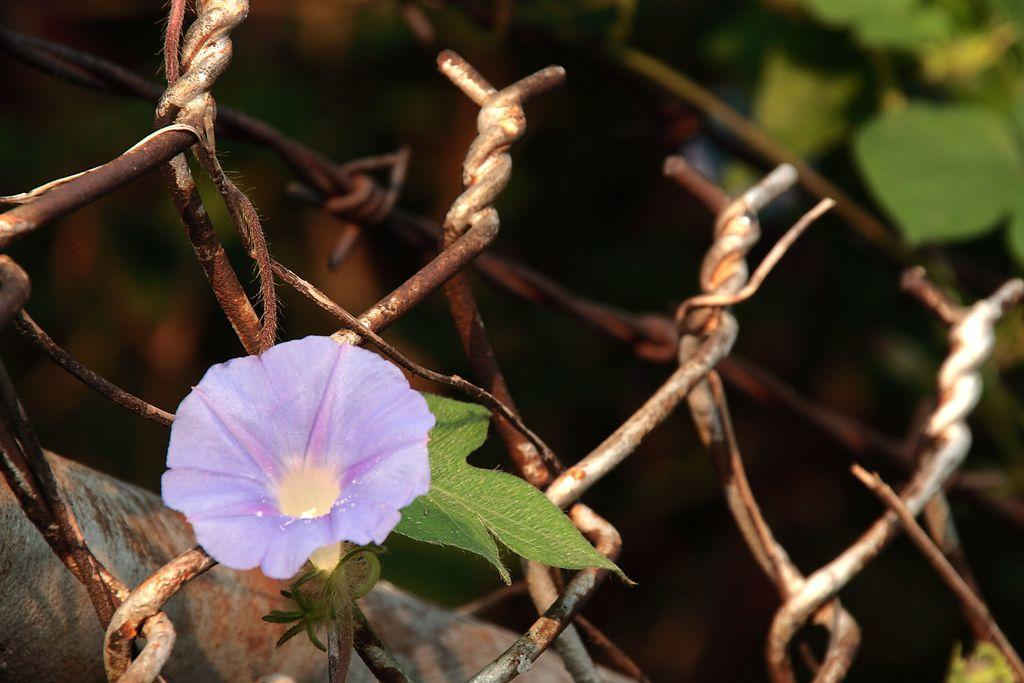What type of plant can be seen in the image? There is a flower in the image. Are there any other plants visible in the image? Yes, there are plants in the image. What type of structure is present in the image? There is fencing in the image. Can you describe the background of the image? The background of the image is blurred. What type of comb is being used to play volleyball in the image? There is no comb or volleyball present in the image. Is there a boat visible in the image? No, there is no boat present in the image. 